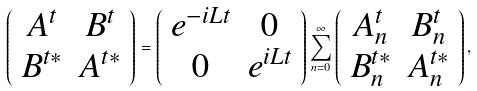<formula> <loc_0><loc_0><loc_500><loc_500>\left ( \begin{array} { c c } A ^ { t } & B ^ { t } \\ B ^ { t * } & A ^ { t * } \end{array} \right ) = \left ( \begin{array} { c c } e ^ { - i L t } & 0 \\ 0 & e ^ { i L t } \end{array} \right ) \sum _ { n = 0 } ^ { \infty } \left ( \begin{array} { c c } A ^ { t } _ { n } & B ^ { t } _ { n } \\ B ^ { t * } _ { n } & A ^ { t * } _ { n } \end{array} \right ) ,</formula> 